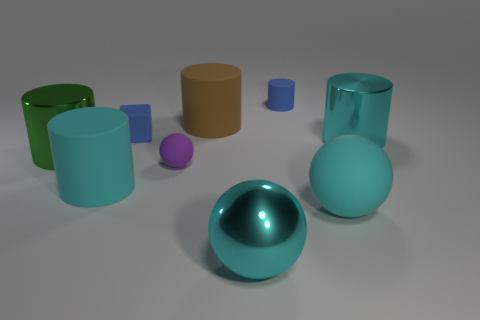Subtract all cyan cylinders. How many cylinders are left? 3 Subtract all big green cylinders. How many cylinders are left? 4 Subtract all blue cylinders. Subtract all blue balls. How many cylinders are left? 4 Subtract all cubes. How many objects are left? 8 Add 9 large green metal objects. How many large green metal objects are left? 10 Add 6 large brown cylinders. How many large brown cylinders exist? 7 Subtract 1 cyan balls. How many objects are left? 8 Subtract all big blue metallic balls. Subtract all big green metallic cylinders. How many objects are left? 8 